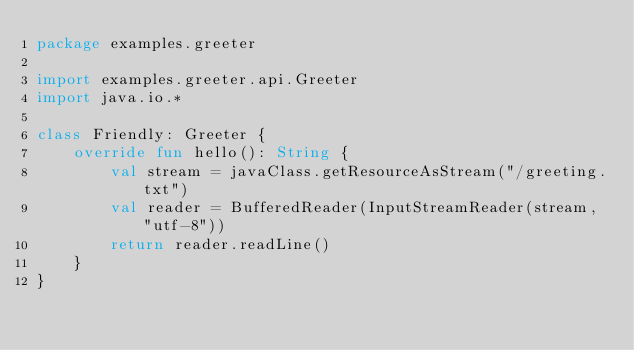<code> <loc_0><loc_0><loc_500><loc_500><_Kotlin_>package examples.greeter

import examples.greeter.api.Greeter
import java.io.*

class Friendly: Greeter {
    override fun hello(): String {
        val stream = javaClass.getResourceAsStream("/greeting.txt")
        val reader = BufferedReader(InputStreamReader(stream, "utf-8"))
        return reader.readLine()
    }
}
</code> 